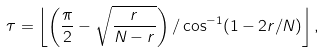<formula> <loc_0><loc_0><loc_500><loc_500>\tau = \left \lfloor \left ( \frac { \pi } { 2 } - \sqrt { \frac { r } { N - r } } \right ) / \cos ^ { - 1 } ( 1 - 2 r / N ) \right \rfloor ,</formula> 